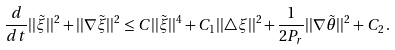Convert formula to latex. <formula><loc_0><loc_0><loc_500><loc_500>\frac { d } { d t } | | \tilde { \xi } | | ^ { 2 } + | | \nabla \tilde { \xi } | | ^ { 2 } \leq C | | \tilde { \xi } | | ^ { 4 } + C _ { 1 } | | \triangle \xi | | ^ { 2 } + \frac { 1 } { 2 P _ { r } } | | \nabla \tilde { \theta } | | ^ { 2 } + C _ { 2 } \, .</formula> 